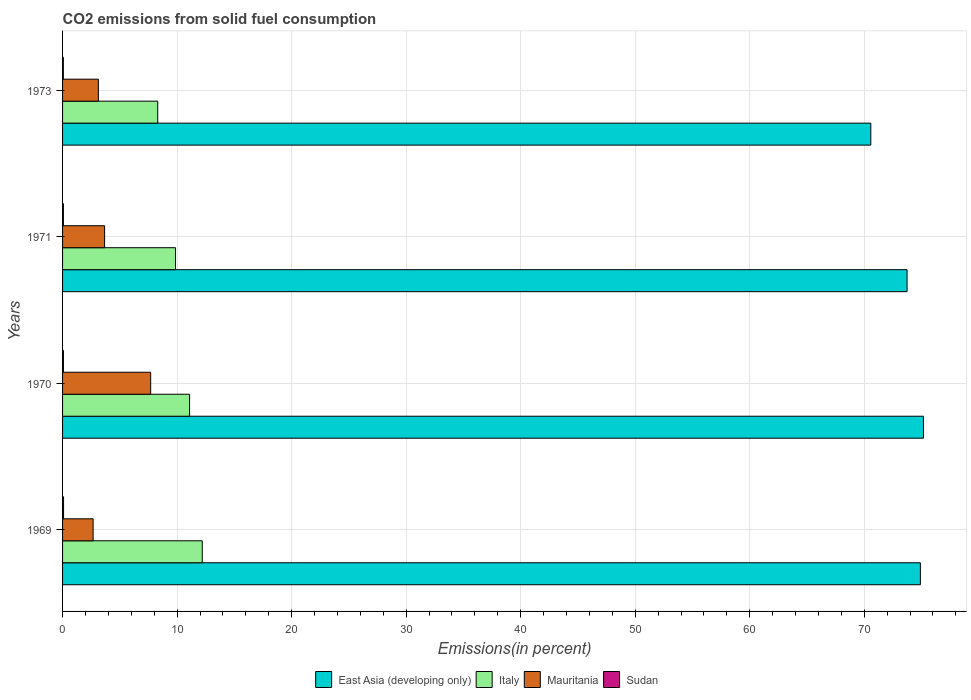How many different coloured bars are there?
Give a very brief answer. 4. How many groups of bars are there?
Provide a succinct answer. 4. Are the number of bars per tick equal to the number of legend labels?
Your answer should be very brief. Yes. What is the label of the 2nd group of bars from the top?
Provide a succinct answer. 1971. In how many cases, is the number of bars for a given year not equal to the number of legend labels?
Ensure brevity in your answer.  0. What is the total CO2 emitted in Mauritania in 1969?
Provide a succinct answer. 2.67. Across all years, what is the maximum total CO2 emitted in East Asia (developing only)?
Make the answer very short. 75.17. Across all years, what is the minimum total CO2 emitted in Sudan?
Offer a very short reply. 0.07. In which year was the total CO2 emitted in Sudan maximum?
Offer a terse response. 1969. What is the total total CO2 emitted in Mauritania in the graph?
Keep it short and to the point. 17.15. What is the difference between the total CO2 emitted in Italy in 1970 and that in 1973?
Offer a terse response. 2.78. What is the difference between the total CO2 emitted in East Asia (developing only) in 1970 and the total CO2 emitted in Italy in 1969?
Ensure brevity in your answer.  62.97. What is the average total CO2 emitted in East Asia (developing only) per year?
Provide a succinct answer. 73.59. In the year 1973, what is the difference between the total CO2 emitted in East Asia (developing only) and total CO2 emitted in Italy?
Offer a terse response. 62.26. In how many years, is the total CO2 emitted in Mauritania greater than 72 %?
Your answer should be very brief. 0. What is the ratio of the total CO2 emitted in Italy in 1970 to that in 1971?
Ensure brevity in your answer.  1.12. Is the total CO2 emitted in Sudan in 1969 less than that in 1970?
Offer a terse response. No. Is the difference between the total CO2 emitted in East Asia (developing only) in 1969 and 1971 greater than the difference between the total CO2 emitted in Italy in 1969 and 1971?
Keep it short and to the point. No. What is the difference between the highest and the second highest total CO2 emitted in Sudan?
Give a very brief answer. 0.01. What is the difference between the highest and the lowest total CO2 emitted in East Asia (developing only)?
Give a very brief answer. 4.6. In how many years, is the total CO2 emitted in Italy greater than the average total CO2 emitted in Italy taken over all years?
Ensure brevity in your answer.  2. Is the sum of the total CO2 emitted in Sudan in 1970 and 1971 greater than the maximum total CO2 emitted in East Asia (developing only) across all years?
Your answer should be very brief. No. Is it the case that in every year, the sum of the total CO2 emitted in Italy and total CO2 emitted in Sudan is greater than the sum of total CO2 emitted in Mauritania and total CO2 emitted in East Asia (developing only)?
Your answer should be very brief. No. What does the 4th bar from the bottom in 1969 represents?
Make the answer very short. Sudan. How many bars are there?
Offer a very short reply. 16. How many years are there in the graph?
Provide a succinct answer. 4. What is the difference between two consecutive major ticks on the X-axis?
Your answer should be compact. 10. Are the values on the major ticks of X-axis written in scientific E-notation?
Your answer should be compact. No. Does the graph contain any zero values?
Your answer should be very brief. No. Does the graph contain grids?
Ensure brevity in your answer.  Yes. How are the legend labels stacked?
Your answer should be compact. Horizontal. What is the title of the graph?
Make the answer very short. CO2 emissions from solid fuel consumption. What is the label or title of the X-axis?
Ensure brevity in your answer.  Emissions(in percent). What is the label or title of the Y-axis?
Your answer should be very brief. Years. What is the Emissions(in percent) of East Asia (developing only) in 1969?
Provide a succinct answer. 74.9. What is the Emissions(in percent) of Italy in 1969?
Make the answer very short. 12.2. What is the Emissions(in percent) in Mauritania in 1969?
Give a very brief answer. 2.67. What is the Emissions(in percent) in Sudan in 1969?
Offer a very short reply. 0.09. What is the Emissions(in percent) in East Asia (developing only) in 1970?
Your answer should be compact. 75.17. What is the Emissions(in percent) in Italy in 1970?
Provide a short and direct response. 11.09. What is the Emissions(in percent) of Mauritania in 1970?
Your answer should be very brief. 7.69. What is the Emissions(in percent) of Sudan in 1970?
Offer a very short reply. 0.08. What is the Emissions(in percent) of East Asia (developing only) in 1971?
Your response must be concise. 73.74. What is the Emissions(in percent) in Italy in 1971?
Offer a terse response. 9.86. What is the Emissions(in percent) in Mauritania in 1971?
Your answer should be very brief. 3.67. What is the Emissions(in percent) in Sudan in 1971?
Provide a succinct answer. 0.07. What is the Emissions(in percent) in East Asia (developing only) in 1973?
Offer a terse response. 70.57. What is the Emissions(in percent) in Italy in 1973?
Ensure brevity in your answer.  8.31. What is the Emissions(in percent) in Mauritania in 1973?
Provide a succinct answer. 3.12. What is the Emissions(in percent) of Sudan in 1973?
Provide a short and direct response. 0.07. Across all years, what is the maximum Emissions(in percent) in East Asia (developing only)?
Provide a succinct answer. 75.17. Across all years, what is the maximum Emissions(in percent) of Italy?
Make the answer very short. 12.2. Across all years, what is the maximum Emissions(in percent) of Mauritania?
Your answer should be very brief. 7.69. Across all years, what is the maximum Emissions(in percent) in Sudan?
Offer a terse response. 0.09. Across all years, what is the minimum Emissions(in percent) in East Asia (developing only)?
Give a very brief answer. 70.57. Across all years, what is the minimum Emissions(in percent) of Italy?
Give a very brief answer. 8.31. Across all years, what is the minimum Emissions(in percent) of Mauritania?
Ensure brevity in your answer.  2.67. Across all years, what is the minimum Emissions(in percent) of Sudan?
Ensure brevity in your answer.  0.07. What is the total Emissions(in percent) of East Asia (developing only) in the graph?
Offer a very short reply. 294.37. What is the total Emissions(in percent) in Italy in the graph?
Give a very brief answer. 41.46. What is the total Emissions(in percent) in Mauritania in the graph?
Keep it short and to the point. 17.15. What is the total Emissions(in percent) in Sudan in the graph?
Make the answer very short. 0.3. What is the difference between the Emissions(in percent) in East Asia (developing only) in 1969 and that in 1970?
Your response must be concise. -0.27. What is the difference between the Emissions(in percent) in Italy in 1969 and that in 1970?
Give a very brief answer. 1.11. What is the difference between the Emissions(in percent) of Mauritania in 1969 and that in 1970?
Provide a succinct answer. -5.03. What is the difference between the Emissions(in percent) of Sudan in 1969 and that in 1970?
Ensure brevity in your answer.  0.01. What is the difference between the Emissions(in percent) of East Asia (developing only) in 1969 and that in 1971?
Offer a very short reply. 1.16. What is the difference between the Emissions(in percent) in Italy in 1969 and that in 1971?
Ensure brevity in your answer.  2.33. What is the difference between the Emissions(in percent) of Mauritania in 1969 and that in 1971?
Give a very brief answer. -1. What is the difference between the Emissions(in percent) in Sudan in 1969 and that in 1971?
Make the answer very short. 0.01. What is the difference between the Emissions(in percent) in East Asia (developing only) in 1969 and that in 1973?
Your response must be concise. 4.33. What is the difference between the Emissions(in percent) in Italy in 1969 and that in 1973?
Ensure brevity in your answer.  3.89. What is the difference between the Emissions(in percent) in Mauritania in 1969 and that in 1973?
Ensure brevity in your answer.  -0.46. What is the difference between the Emissions(in percent) in Sudan in 1969 and that in 1973?
Ensure brevity in your answer.  0.02. What is the difference between the Emissions(in percent) in East Asia (developing only) in 1970 and that in 1971?
Your response must be concise. 1.43. What is the difference between the Emissions(in percent) of Italy in 1970 and that in 1971?
Your answer should be compact. 1.23. What is the difference between the Emissions(in percent) of Mauritania in 1970 and that in 1971?
Make the answer very short. 4.02. What is the difference between the Emissions(in percent) in Sudan in 1970 and that in 1971?
Offer a very short reply. 0. What is the difference between the Emissions(in percent) in East Asia (developing only) in 1970 and that in 1973?
Ensure brevity in your answer.  4.6. What is the difference between the Emissions(in percent) in Italy in 1970 and that in 1973?
Provide a succinct answer. 2.78. What is the difference between the Emissions(in percent) in Mauritania in 1970 and that in 1973?
Keep it short and to the point. 4.57. What is the difference between the Emissions(in percent) of Sudan in 1970 and that in 1973?
Your response must be concise. 0.01. What is the difference between the Emissions(in percent) in East Asia (developing only) in 1971 and that in 1973?
Make the answer very short. 3.16. What is the difference between the Emissions(in percent) in Italy in 1971 and that in 1973?
Offer a terse response. 1.55. What is the difference between the Emissions(in percent) in Mauritania in 1971 and that in 1973?
Give a very brief answer. 0.54. What is the difference between the Emissions(in percent) of Sudan in 1971 and that in 1973?
Your answer should be very brief. 0.01. What is the difference between the Emissions(in percent) in East Asia (developing only) in 1969 and the Emissions(in percent) in Italy in 1970?
Your answer should be very brief. 63.81. What is the difference between the Emissions(in percent) of East Asia (developing only) in 1969 and the Emissions(in percent) of Mauritania in 1970?
Give a very brief answer. 67.21. What is the difference between the Emissions(in percent) of East Asia (developing only) in 1969 and the Emissions(in percent) of Sudan in 1970?
Your answer should be very brief. 74.82. What is the difference between the Emissions(in percent) in Italy in 1969 and the Emissions(in percent) in Mauritania in 1970?
Keep it short and to the point. 4.5. What is the difference between the Emissions(in percent) in Italy in 1969 and the Emissions(in percent) in Sudan in 1970?
Your answer should be very brief. 12.12. What is the difference between the Emissions(in percent) of Mauritania in 1969 and the Emissions(in percent) of Sudan in 1970?
Provide a succinct answer. 2.59. What is the difference between the Emissions(in percent) of East Asia (developing only) in 1969 and the Emissions(in percent) of Italy in 1971?
Make the answer very short. 65.04. What is the difference between the Emissions(in percent) in East Asia (developing only) in 1969 and the Emissions(in percent) in Mauritania in 1971?
Ensure brevity in your answer.  71.23. What is the difference between the Emissions(in percent) of East Asia (developing only) in 1969 and the Emissions(in percent) of Sudan in 1971?
Offer a terse response. 74.83. What is the difference between the Emissions(in percent) in Italy in 1969 and the Emissions(in percent) in Mauritania in 1971?
Offer a terse response. 8.53. What is the difference between the Emissions(in percent) in Italy in 1969 and the Emissions(in percent) in Sudan in 1971?
Provide a short and direct response. 12.12. What is the difference between the Emissions(in percent) in Mauritania in 1969 and the Emissions(in percent) in Sudan in 1971?
Your answer should be compact. 2.59. What is the difference between the Emissions(in percent) in East Asia (developing only) in 1969 and the Emissions(in percent) in Italy in 1973?
Your response must be concise. 66.59. What is the difference between the Emissions(in percent) of East Asia (developing only) in 1969 and the Emissions(in percent) of Mauritania in 1973?
Offer a very short reply. 71.77. What is the difference between the Emissions(in percent) of East Asia (developing only) in 1969 and the Emissions(in percent) of Sudan in 1973?
Keep it short and to the point. 74.83. What is the difference between the Emissions(in percent) of Italy in 1969 and the Emissions(in percent) of Mauritania in 1973?
Your answer should be very brief. 9.07. What is the difference between the Emissions(in percent) in Italy in 1969 and the Emissions(in percent) in Sudan in 1973?
Offer a terse response. 12.13. What is the difference between the Emissions(in percent) of Mauritania in 1969 and the Emissions(in percent) of Sudan in 1973?
Offer a very short reply. 2.6. What is the difference between the Emissions(in percent) of East Asia (developing only) in 1970 and the Emissions(in percent) of Italy in 1971?
Offer a terse response. 65.3. What is the difference between the Emissions(in percent) in East Asia (developing only) in 1970 and the Emissions(in percent) in Mauritania in 1971?
Provide a succinct answer. 71.5. What is the difference between the Emissions(in percent) of East Asia (developing only) in 1970 and the Emissions(in percent) of Sudan in 1971?
Offer a terse response. 75.09. What is the difference between the Emissions(in percent) of Italy in 1970 and the Emissions(in percent) of Mauritania in 1971?
Provide a short and direct response. 7.42. What is the difference between the Emissions(in percent) in Italy in 1970 and the Emissions(in percent) in Sudan in 1971?
Ensure brevity in your answer.  11.02. What is the difference between the Emissions(in percent) in Mauritania in 1970 and the Emissions(in percent) in Sudan in 1971?
Your answer should be very brief. 7.62. What is the difference between the Emissions(in percent) in East Asia (developing only) in 1970 and the Emissions(in percent) in Italy in 1973?
Provide a succinct answer. 66.86. What is the difference between the Emissions(in percent) of East Asia (developing only) in 1970 and the Emissions(in percent) of Mauritania in 1973?
Provide a succinct answer. 72.04. What is the difference between the Emissions(in percent) in East Asia (developing only) in 1970 and the Emissions(in percent) in Sudan in 1973?
Ensure brevity in your answer.  75.1. What is the difference between the Emissions(in percent) in Italy in 1970 and the Emissions(in percent) in Mauritania in 1973?
Your response must be concise. 7.96. What is the difference between the Emissions(in percent) in Italy in 1970 and the Emissions(in percent) in Sudan in 1973?
Your answer should be very brief. 11.02. What is the difference between the Emissions(in percent) in Mauritania in 1970 and the Emissions(in percent) in Sudan in 1973?
Your response must be concise. 7.62. What is the difference between the Emissions(in percent) in East Asia (developing only) in 1971 and the Emissions(in percent) in Italy in 1973?
Provide a succinct answer. 65.43. What is the difference between the Emissions(in percent) in East Asia (developing only) in 1971 and the Emissions(in percent) in Mauritania in 1973?
Make the answer very short. 70.61. What is the difference between the Emissions(in percent) of East Asia (developing only) in 1971 and the Emissions(in percent) of Sudan in 1973?
Provide a short and direct response. 73.67. What is the difference between the Emissions(in percent) in Italy in 1971 and the Emissions(in percent) in Mauritania in 1973?
Keep it short and to the point. 6.74. What is the difference between the Emissions(in percent) of Italy in 1971 and the Emissions(in percent) of Sudan in 1973?
Your answer should be compact. 9.8. What is the difference between the Emissions(in percent) of Mauritania in 1971 and the Emissions(in percent) of Sudan in 1973?
Provide a succinct answer. 3.6. What is the average Emissions(in percent) of East Asia (developing only) per year?
Offer a very short reply. 73.59. What is the average Emissions(in percent) in Italy per year?
Provide a succinct answer. 10.36. What is the average Emissions(in percent) of Mauritania per year?
Offer a terse response. 4.29. What is the average Emissions(in percent) of Sudan per year?
Your answer should be very brief. 0.08. In the year 1969, what is the difference between the Emissions(in percent) of East Asia (developing only) and Emissions(in percent) of Italy?
Provide a succinct answer. 62.7. In the year 1969, what is the difference between the Emissions(in percent) in East Asia (developing only) and Emissions(in percent) in Mauritania?
Offer a very short reply. 72.23. In the year 1969, what is the difference between the Emissions(in percent) of East Asia (developing only) and Emissions(in percent) of Sudan?
Your answer should be compact. 74.81. In the year 1969, what is the difference between the Emissions(in percent) of Italy and Emissions(in percent) of Mauritania?
Make the answer very short. 9.53. In the year 1969, what is the difference between the Emissions(in percent) of Italy and Emissions(in percent) of Sudan?
Make the answer very short. 12.11. In the year 1969, what is the difference between the Emissions(in percent) of Mauritania and Emissions(in percent) of Sudan?
Your response must be concise. 2.58. In the year 1970, what is the difference between the Emissions(in percent) of East Asia (developing only) and Emissions(in percent) of Italy?
Ensure brevity in your answer.  64.08. In the year 1970, what is the difference between the Emissions(in percent) in East Asia (developing only) and Emissions(in percent) in Mauritania?
Offer a terse response. 67.47. In the year 1970, what is the difference between the Emissions(in percent) of East Asia (developing only) and Emissions(in percent) of Sudan?
Your answer should be very brief. 75.09. In the year 1970, what is the difference between the Emissions(in percent) of Italy and Emissions(in percent) of Mauritania?
Offer a terse response. 3.4. In the year 1970, what is the difference between the Emissions(in percent) in Italy and Emissions(in percent) in Sudan?
Provide a short and direct response. 11.01. In the year 1970, what is the difference between the Emissions(in percent) in Mauritania and Emissions(in percent) in Sudan?
Your response must be concise. 7.62. In the year 1971, what is the difference between the Emissions(in percent) of East Asia (developing only) and Emissions(in percent) of Italy?
Your answer should be very brief. 63.87. In the year 1971, what is the difference between the Emissions(in percent) of East Asia (developing only) and Emissions(in percent) of Mauritania?
Your answer should be compact. 70.07. In the year 1971, what is the difference between the Emissions(in percent) of East Asia (developing only) and Emissions(in percent) of Sudan?
Your answer should be compact. 73.66. In the year 1971, what is the difference between the Emissions(in percent) in Italy and Emissions(in percent) in Mauritania?
Provide a short and direct response. 6.19. In the year 1971, what is the difference between the Emissions(in percent) in Italy and Emissions(in percent) in Sudan?
Make the answer very short. 9.79. In the year 1971, what is the difference between the Emissions(in percent) in Mauritania and Emissions(in percent) in Sudan?
Offer a terse response. 3.6. In the year 1973, what is the difference between the Emissions(in percent) of East Asia (developing only) and Emissions(in percent) of Italy?
Offer a terse response. 62.26. In the year 1973, what is the difference between the Emissions(in percent) of East Asia (developing only) and Emissions(in percent) of Mauritania?
Keep it short and to the point. 67.45. In the year 1973, what is the difference between the Emissions(in percent) of East Asia (developing only) and Emissions(in percent) of Sudan?
Your response must be concise. 70.5. In the year 1973, what is the difference between the Emissions(in percent) of Italy and Emissions(in percent) of Mauritania?
Your answer should be compact. 5.18. In the year 1973, what is the difference between the Emissions(in percent) of Italy and Emissions(in percent) of Sudan?
Ensure brevity in your answer.  8.24. In the year 1973, what is the difference between the Emissions(in percent) in Mauritania and Emissions(in percent) in Sudan?
Provide a succinct answer. 3.06. What is the ratio of the Emissions(in percent) of Italy in 1969 to that in 1970?
Your answer should be very brief. 1.1. What is the ratio of the Emissions(in percent) in Mauritania in 1969 to that in 1970?
Provide a short and direct response. 0.35. What is the ratio of the Emissions(in percent) in Sudan in 1969 to that in 1970?
Give a very brief answer. 1.16. What is the ratio of the Emissions(in percent) of East Asia (developing only) in 1969 to that in 1971?
Provide a short and direct response. 1.02. What is the ratio of the Emissions(in percent) of Italy in 1969 to that in 1971?
Give a very brief answer. 1.24. What is the ratio of the Emissions(in percent) in Mauritania in 1969 to that in 1971?
Keep it short and to the point. 0.73. What is the ratio of the Emissions(in percent) in Sudan in 1969 to that in 1971?
Provide a succinct answer. 1.19. What is the ratio of the Emissions(in percent) in East Asia (developing only) in 1969 to that in 1973?
Give a very brief answer. 1.06. What is the ratio of the Emissions(in percent) in Italy in 1969 to that in 1973?
Offer a very short reply. 1.47. What is the ratio of the Emissions(in percent) of Mauritania in 1969 to that in 1973?
Your answer should be very brief. 0.85. What is the ratio of the Emissions(in percent) in Sudan in 1969 to that in 1973?
Your answer should be compact. 1.3. What is the ratio of the Emissions(in percent) of East Asia (developing only) in 1970 to that in 1971?
Keep it short and to the point. 1.02. What is the ratio of the Emissions(in percent) of Italy in 1970 to that in 1971?
Offer a terse response. 1.12. What is the ratio of the Emissions(in percent) in Mauritania in 1970 to that in 1971?
Make the answer very short. 2.1. What is the ratio of the Emissions(in percent) of Sudan in 1970 to that in 1971?
Provide a succinct answer. 1.03. What is the ratio of the Emissions(in percent) in East Asia (developing only) in 1970 to that in 1973?
Your response must be concise. 1.07. What is the ratio of the Emissions(in percent) of Italy in 1970 to that in 1973?
Offer a terse response. 1.33. What is the ratio of the Emissions(in percent) of Mauritania in 1970 to that in 1973?
Your answer should be very brief. 2.46. What is the ratio of the Emissions(in percent) of Sudan in 1970 to that in 1973?
Make the answer very short. 1.12. What is the ratio of the Emissions(in percent) in East Asia (developing only) in 1971 to that in 1973?
Provide a succinct answer. 1.04. What is the ratio of the Emissions(in percent) of Italy in 1971 to that in 1973?
Make the answer very short. 1.19. What is the ratio of the Emissions(in percent) in Mauritania in 1971 to that in 1973?
Offer a terse response. 1.17. What is the ratio of the Emissions(in percent) in Sudan in 1971 to that in 1973?
Give a very brief answer. 1.09. What is the difference between the highest and the second highest Emissions(in percent) of East Asia (developing only)?
Your response must be concise. 0.27. What is the difference between the highest and the second highest Emissions(in percent) of Italy?
Make the answer very short. 1.11. What is the difference between the highest and the second highest Emissions(in percent) in Mauritania?
Provide a succinct answer. 4.02. What is the difference between the highest and the second highest Emissions(in percent) in Sudan?
Keep it short and to the point. 0.01. What is the difference between the highest and the lowest Emissions(in percent) of East Asia (developing only)?
Your answer should be very brief. 4.6. What is the difference between the highest and the lowest Emissions(in percent) of Italy?
Your response must be concise. 3.89. What is the difference between the highest and the lowest Emissions(in percent) of Mauritania?
Offer a terse response. 5.03. What is the difference between the highest and the lowest Emissions(in percent) in Sudan?
Offer a terse response. 0.02. 